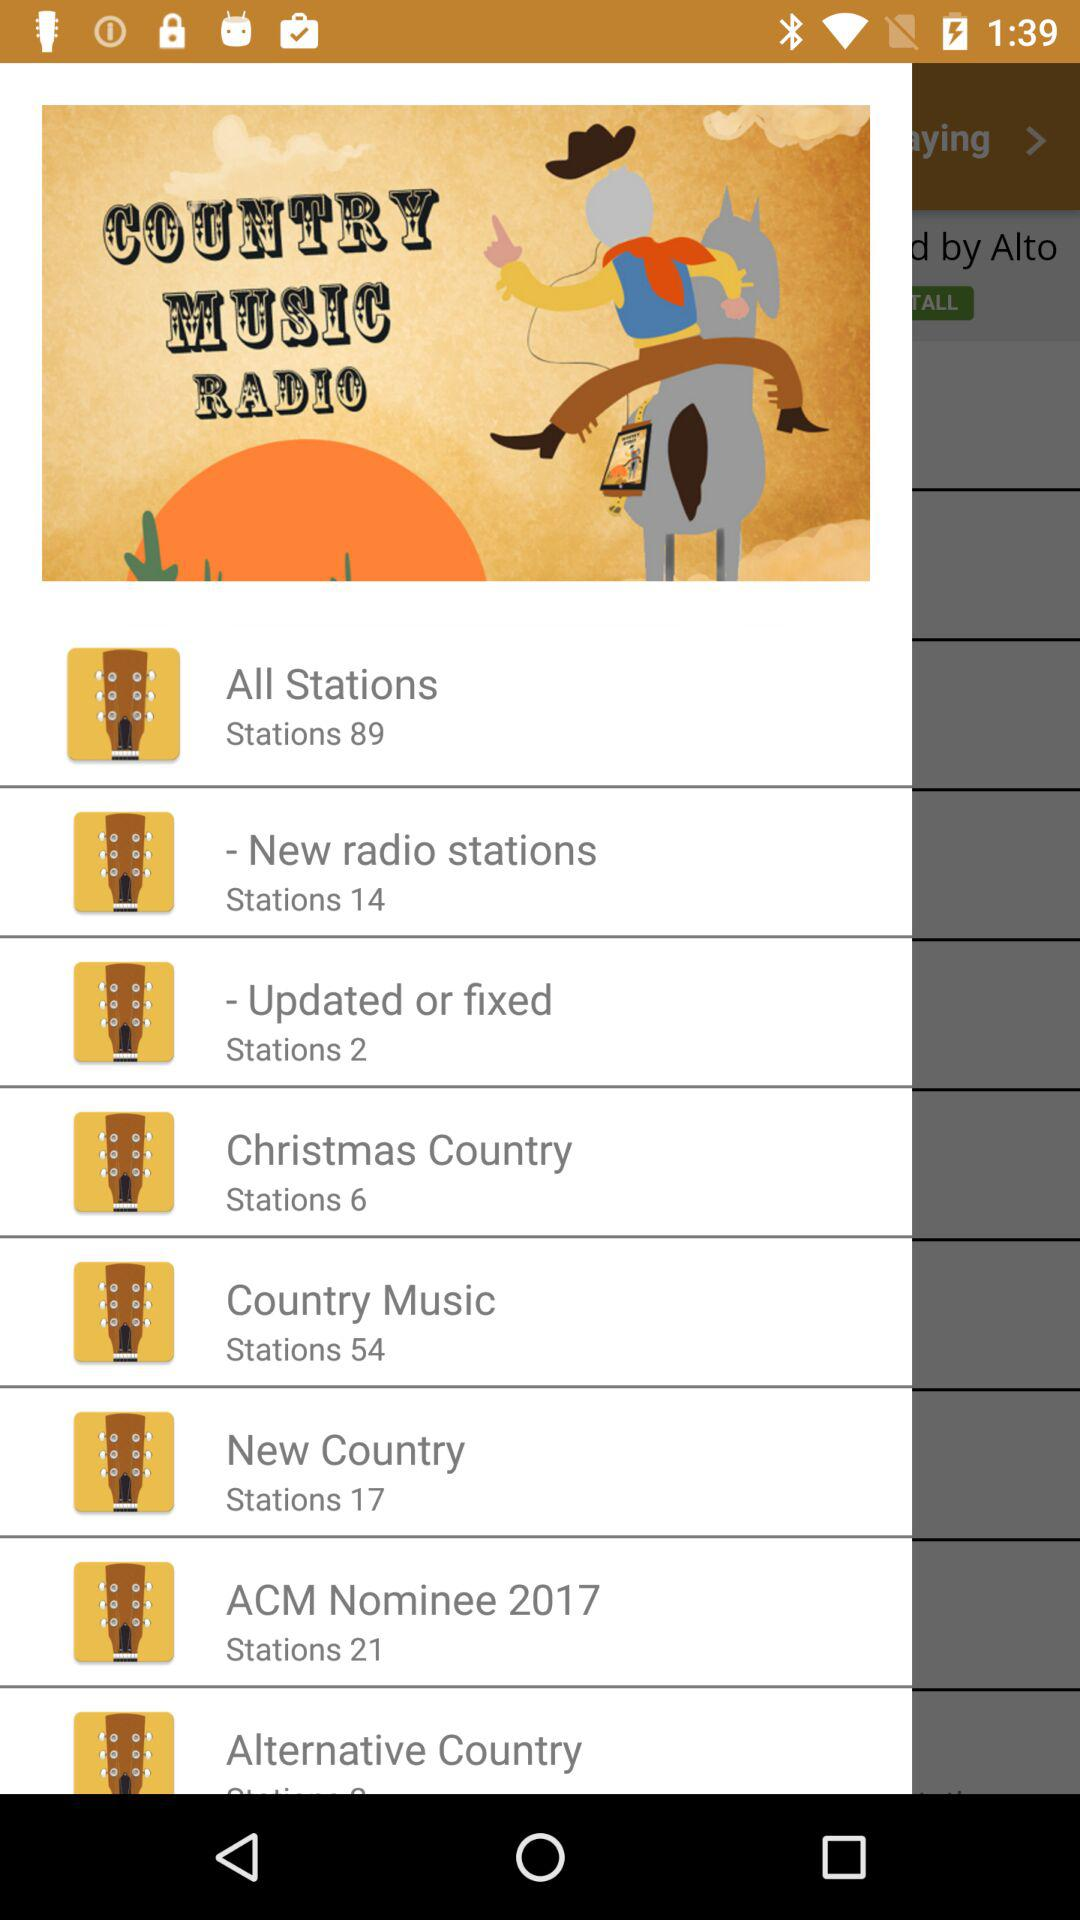How many stations are in the 'New Country' category?
Answer the question using a single word or phrase. 17 